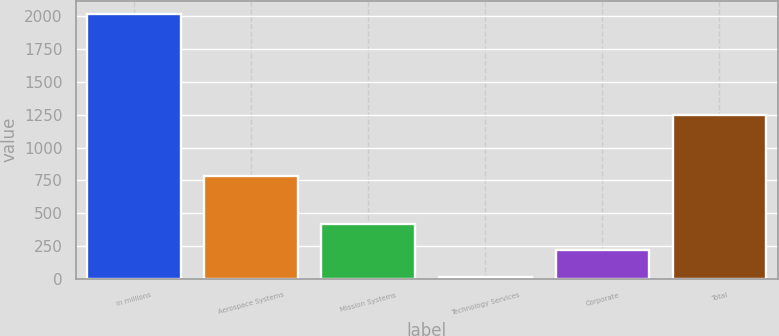Convert chart to OTSL. <chart><loc_0><loc_0><loc_500><loc_500><bar_chart><fcel>in millions<fcel>Aerospace Systems<fcel>Mission Systems<fcel>Technology Services<fcel>Corporate<fcel>Total<nl><fcel>2018<fcel>781<fcel>418<fcel>18<fcel>218<fcel>1249<nl></chart> 